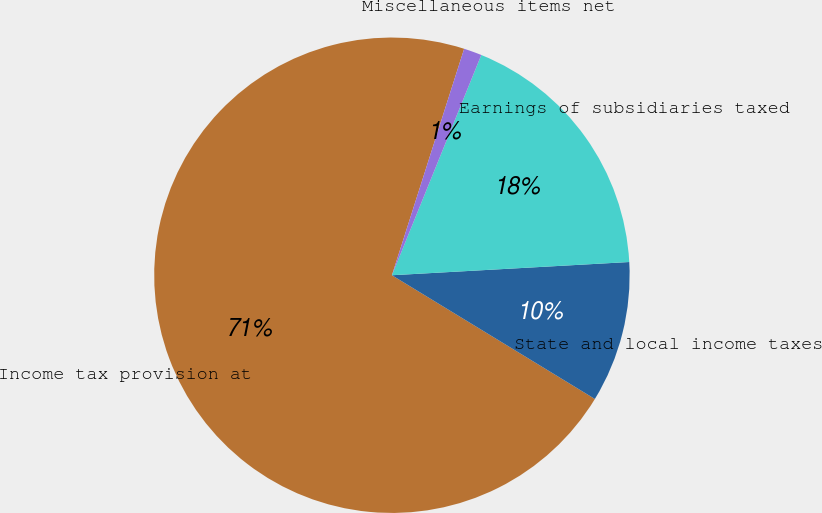<chart> <loc_0><loc_0><loc_500><loc_500><pie_chart><fcel>Income tax provision at<fcel>State and local income taxes<fcel>Earnings of subsidiaries taxed<fcel>Miscellaneous items net<nl><fcel>71.2%<fcel>9.6%<fcel>17.98%<fcel>1.22%<nl></chart> 